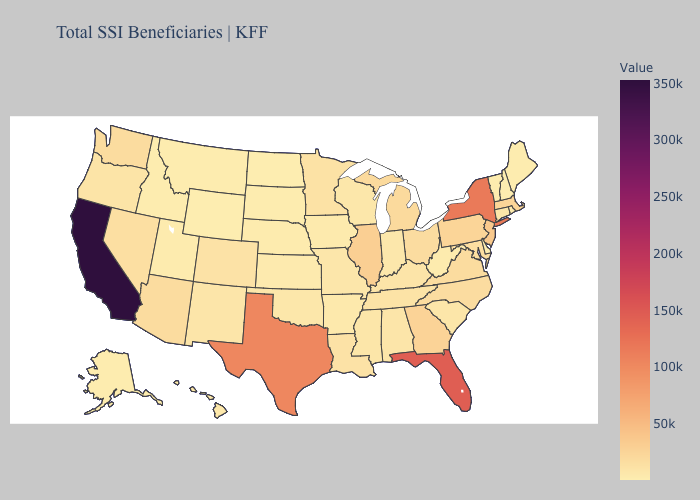Which states have the lowest value in the USA?
Answer briefly. Wyoming. Does Wyoming have the lowest value in the USA?
Be succinct. Yes. Does Wyoming have the lowest value in the West?
Write a very short answer. Yes. Among the states that border Kentucky , which have the lowest value?
Write a very short answer. West Virginia. Which states have the lowest value in the USA?
Concise answer only. Wyoming. 